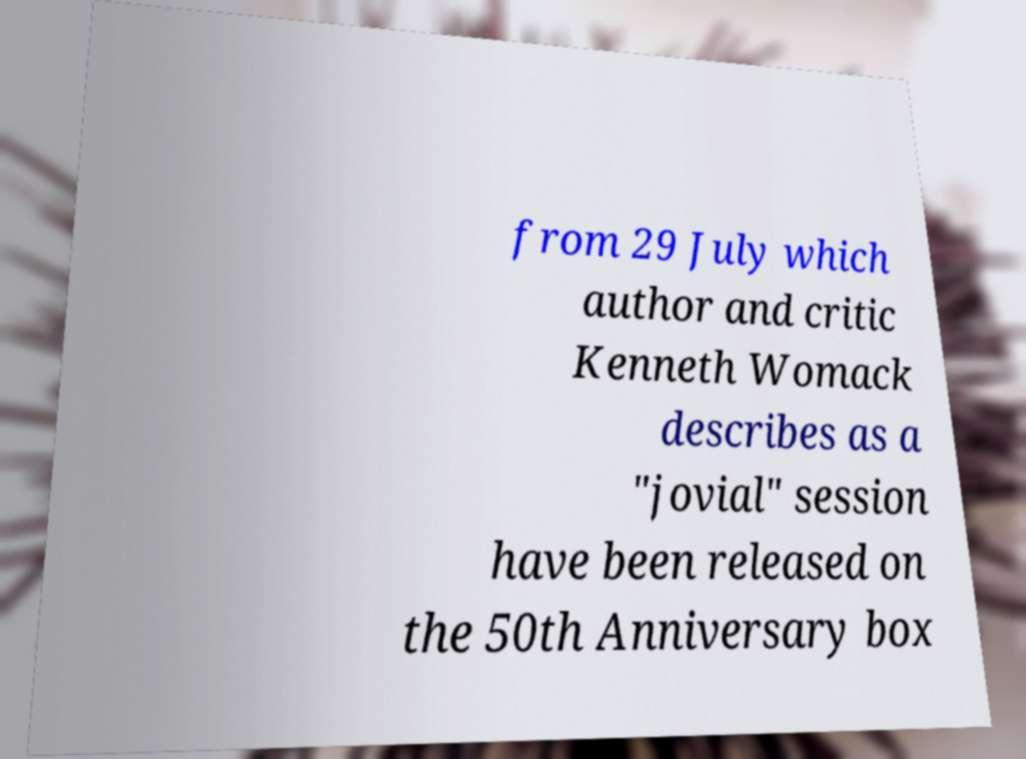Can you read and provide the text displayed in the image?This photo seems to have some interesting text. Can you extract and type it out for me? from 29 July which author and critic Kenneth Womack describes as a "jovial" session have been released on the 50th Anniversary box 